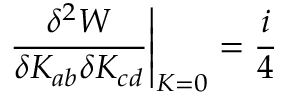<formula> <loc_0><loc_0><loc_500><loc_500>\frac { \delta ^ { 2 } W } { \delta K _ { a b } \delta K _ { c d } } \right | _ { K = 0 } = \frac { i } { 4 }</formula> 